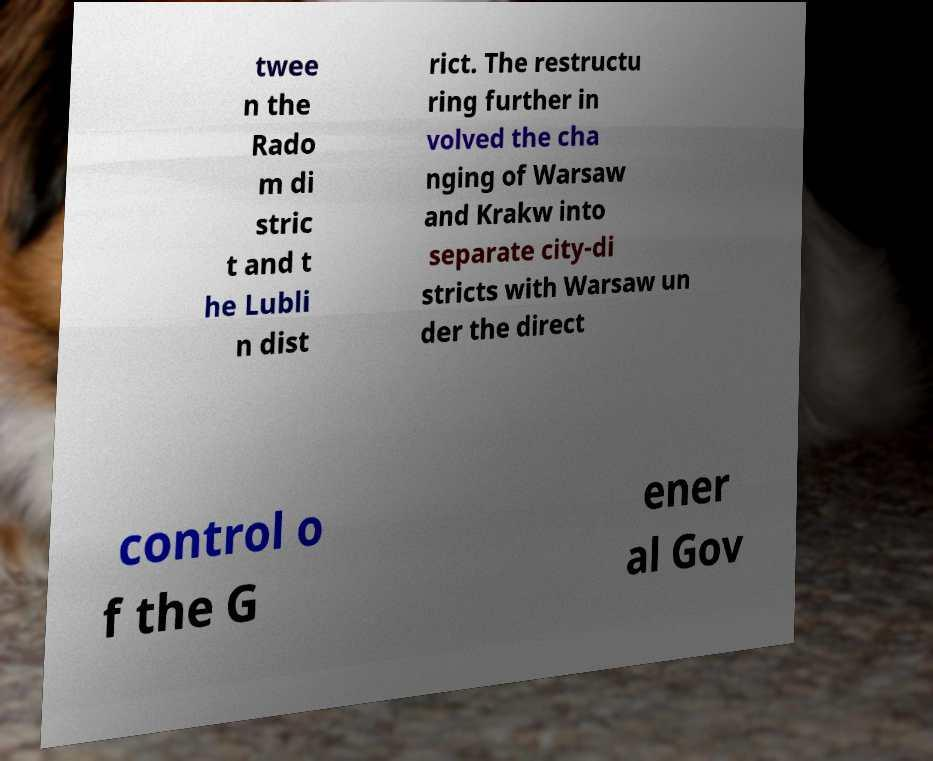Please read and relay the text visible in this image. What does it say? twee n the Rado m di stric t and t he Lubli n dist rict. The restructu ring further in volved the cha nging of Warsaw and Krakw into separate city-di stricts with Warsaw un der the direct control o f the G ener al Gov 